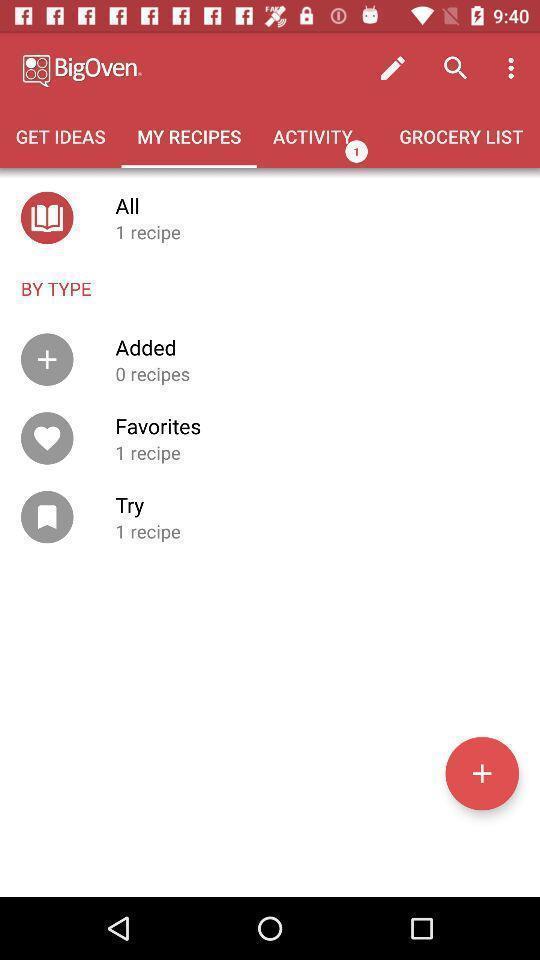Provide a detailed account of this screenshot. Page showing different recipes available in application. 